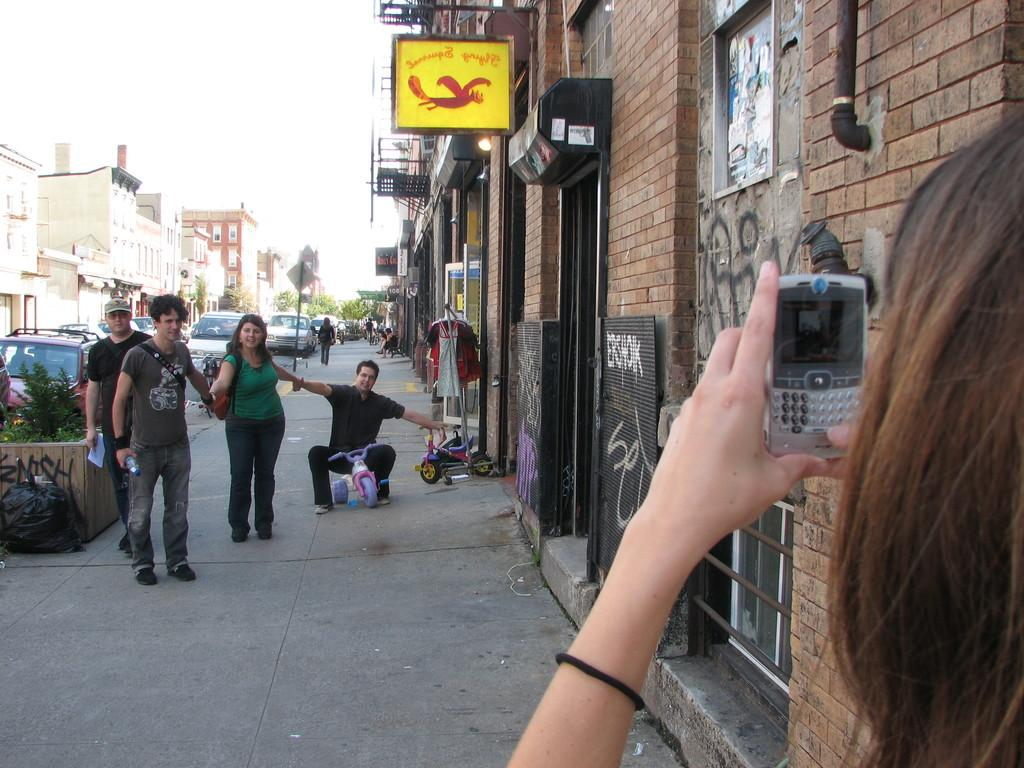What is the person in the image holding? The person is holding a phone in the image. How many people are present in the image? There are four persons in the image. What can be seen in the background of the image? Buildings, cars, and trees are visible in the background of the image. What type of leaf is being used as a calendar in the image? There is no leaf or calendar present in the image. What adjustment is being made to the car in the image? There is no adjustment being made to a car in the image. 